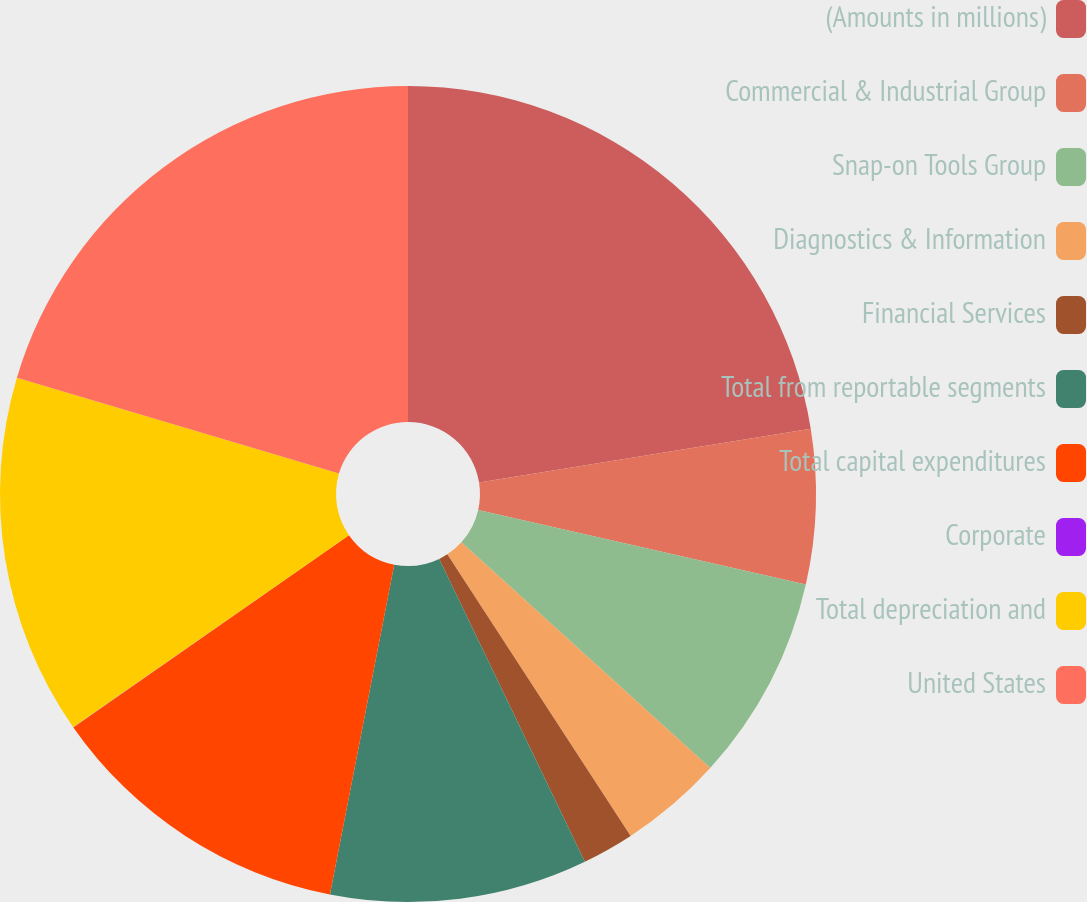Convert chart. <chart><loc_0><loc_0><loc_500><loc_500><pie_chart><fcel>(Amounts in millions)<fcel>Commercial & Industrial Group<fcel>Snap-on Tools Group<fcel>Diagnostics & Information<fcel>Financial Services<fcel>Total from reportable segments<fcel>Total capital expenditures<fcel>Corporate<fcel>Total depreciation and<fcel>United States<nl><fcel>22.44%<fcel>6.12%<fcel>8.16%<fcel>4.09%<fcel>2.05%<fcel>10.2%<fcel>12.24%<fcel>0.01%<fcel>14.28%<fcel>20.4%<nl></chart> 